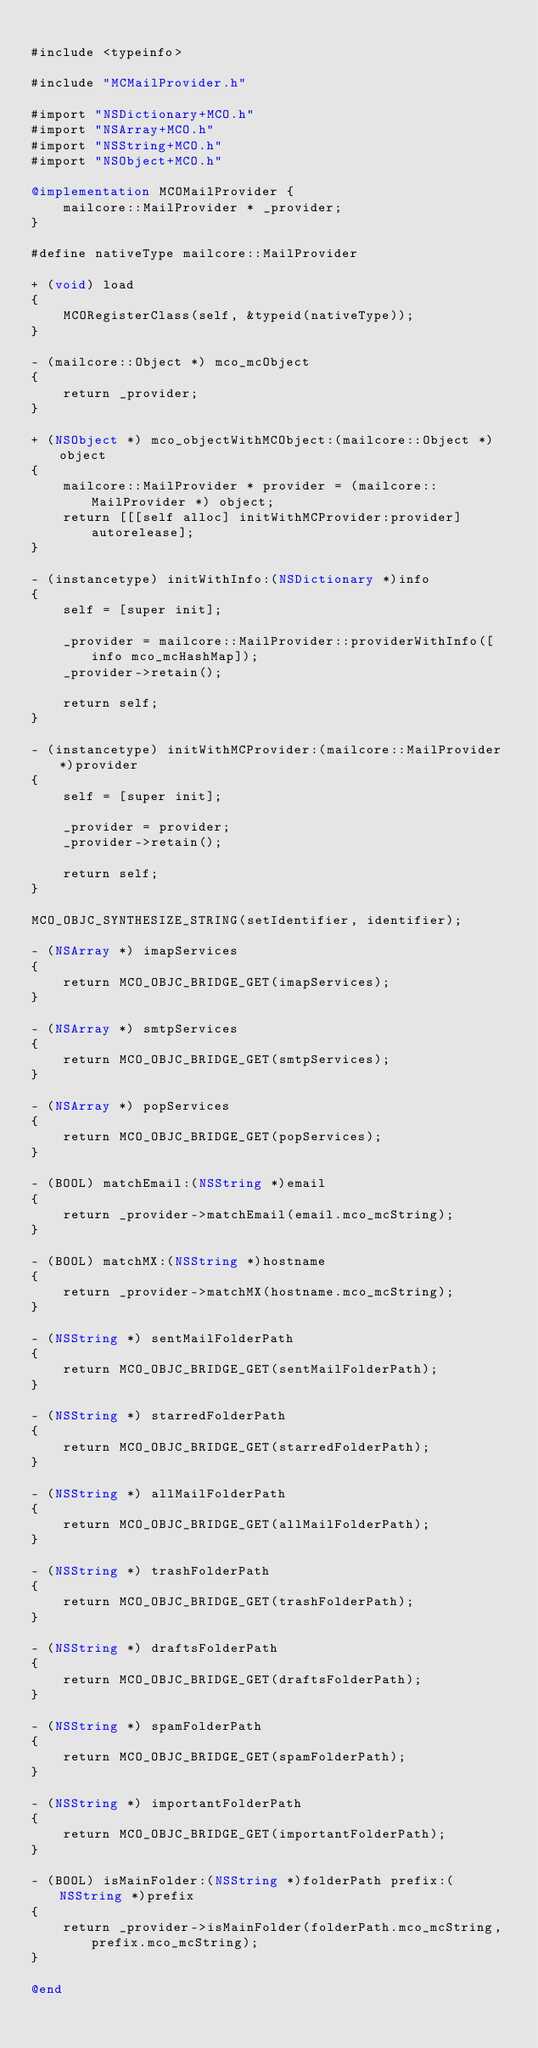Convert code to text. <code><loc_0><loc_0><loc_500><loc_500><_ObjectiveC_>
#include <typeinfo>

#include "MCMailProvider.h"

#import "NSDictionary+MCO.h"
#import "NSArray+MCO.h"
#import "NSString+MCO.h"
#import "NSObject+MCO.h"

@implementation MCOMailProvider {
    mailcore::MailProvider * _provider;
}

#define nativeType mailcore::MailProvider

+ (void) load
{
    MCORegisterClass(self, &typeid(nativeType));
}

- (mailcore::Object *) mco_mcObject
{
    return _provider;
}

+ (NSObject *) mco_objectWithMCObject:(mailcore::Object *)object
{
    mailcore::MailProvider * provider = (mailcore::MailProvider *) object;
    return [[[self alloc] initWithMCProvider:provider] autorelease];
}

- (instancetype) initWithInfo:(NSDictionary *)info
{
    self = [super init];
    
    _provider = mailcore::MailProvider::providerWithInfo([info mco_mcHashMap]);
    _provider->retain();
    
    return self;
}

- (instancetype) initWithMCProvider:(mailcore::MailProvider *)provider
{
    self = [super init];
    
    _provider = provider;
    _provider->retain();
    
    return self;
}

MCO_OBJC_SYNTHESIZE_STRING(setIdentifier, identifier);

- (NSArray *) imapServices
{
    return MCO_OBJC_BRIDGE_GET(imapServices);
}

- (NSArray *) smtpServices
{
    return MCO_OBJC_BRIDGE_GET(smtpServices);
}

- (NSArray *) popServices
{
    return MCO_OBJC_BRIDGE_GET(popServices);
}

- (BOOL) matchEmail:(NSString *)email
{
    return _provider->matchEmail(email.mco_mcString);
}

- (BOOL) matchMX:(NSString *)hostname
{
    return _provider->matchMX(hostname.mco_mcString);
}

- (NSString *) sentMailFolderPath
{
    return MCO_OBJC_BRIDGE_GET(sentMailFolderPath);
}

- (NSString *) starredFolderPath
{
    return MCO_OBJC_BRIDGE_GET(starredFolderPath);
}

- (NSString *) allMailFolderPath
{
    return MCO_OBJC_BRIDGE_GET(allMailFolderPath);
}

- (NSString *) trashFolderPath
{
    return MCO_OBJC_BRIDGE_GET(trashFolderPath);
}

- (NSString *) draftsFolderPath
{
    return MCO_OBJC_BRIDGE_GET(draftsFolderPath);
}

- (NSString *) spamFolderPath
{
    return MCO_OBJC_BRIDGE_GET(spamFolderPath);
}

- (NSString *) importantFolderPath
{
    return MCO_OBJC_BRIDGE_GET(importantFolderPath);
}

- (BOOL) isMainFolder:(NSString *)folderPath prefix:(NSString *)prefix
{
    return _provider->isMainFolder(folderPath.mco_mcString, prefix.mco_mcString);
}

@end
</code> 